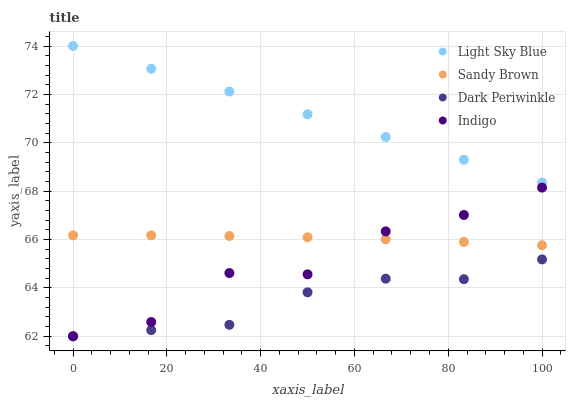Does Dark Periwinkle have the minimum area under the curve?
Answer yes or no. Yes. Does Light Sky Blue have the maximum area under the curve?
Answer yes or no. Yes. Does Sandy Brown have the minimum area under the curve?
Answer yes or no. No. Does Sandy Brown have the maximum area under the curve?
Answer yes or no. No. Is Light Sky Blue the smoothest?
Answer yes or no. Yes. Is Indigo the roughest?
Answer yes or no. Yes. Is Sandy Brown the smoothest?
Answer yes or no. No. Is Sandy Brown the roughest?
Answer yes or no. No. Does Indigo have the lowest value?
Answer yes or no. Yes. Does Sandy Brown have the lowest value?
Answer yes or no. No. Does Light Sky Blue have the highest value?
Answer yes or no. Yes. Does Sandy Brown have the highest value?
Answer yes or no. No. Is Dark Periwinkle less than Light Sky Blue?
Answer yes or no. Yes. Is Light Sky Blue greater than Dark Periwinkle?
Answer yes or no. Yes. Does Indigo intersect Sandy Brown?
Answer yes or no. Yes. Is Indigo less than Sandy Brown?
Answer yes or no. No. Is Indigo greater than Sandy Brown?
Answer yes or no. No. Does Dark Periwinkle intersect Light Sky Blue?
Answer yes or no. No. 